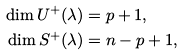<formula> <loc_0><loc_0><loc_500><loc_500>\dim U ^ { + } ( \lambda ) & = p + 1 , \\ \dim S ^ { + } ( \lambda ) & = n - p + 1 ,</formula> 